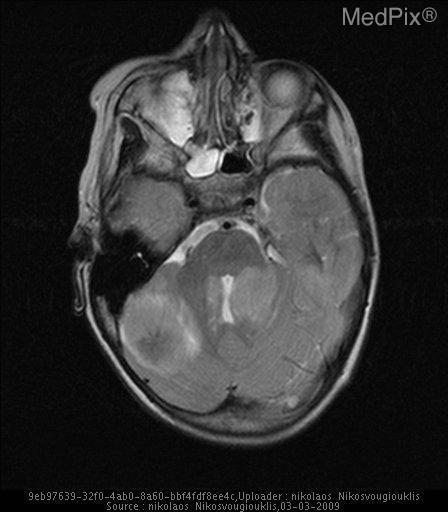Is there a shift of midline structures?
Answer briefly. Yes. What plane of section is the brain taken in?
Keep it brief. Axial. What cut of the brain is this image taken?
Keep it brief. Axial. Which half the cerebellum is the largest mass located?
Quick response, please. Right. Which side of the cerebellum contains the largest mass?
Quick response, please. Right. What type of modality was this image taken?
Short answer required. Mri - t2 weighted. What is the mr weighting in this image?
Be succinct. Mri - t2 weighted. 